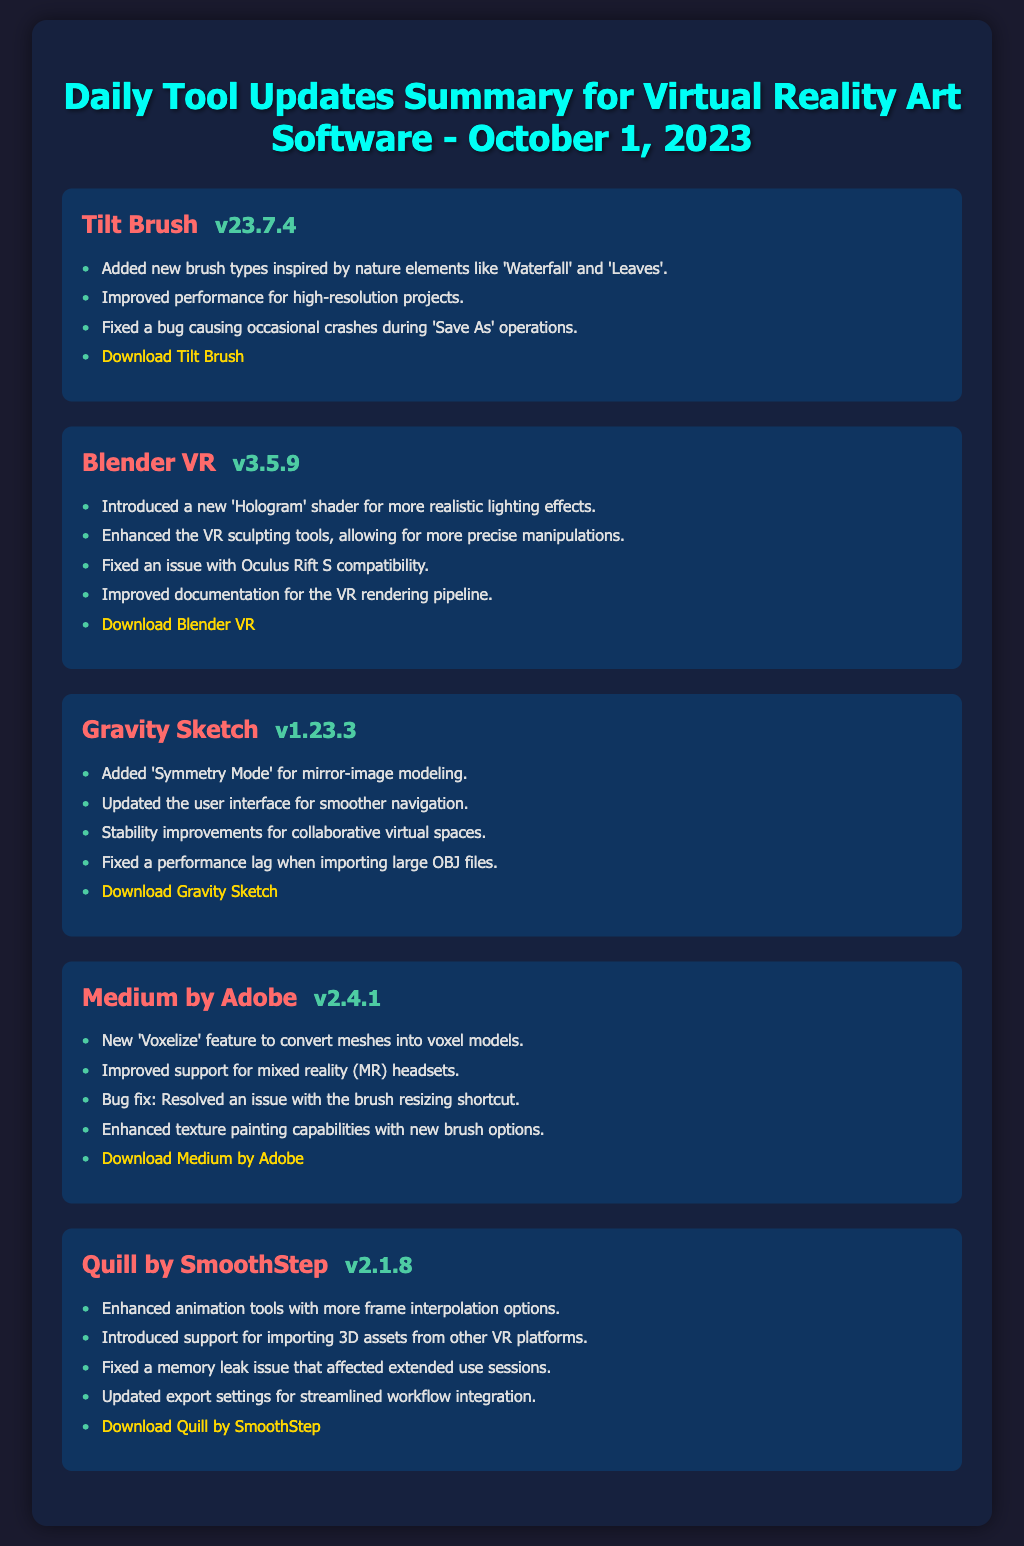What is the latest version of Tilt Brush? The latest version of Tilt Brush listed in the document is v23.7.4.
Answer: v23.7.4 Which new feature was added to Medium by Adobe? A new feature called 'Voxelize' to convert meshes into voxel models was added to Medium by Adobe.
Answer: Voxelize What fixed issue is mentioned for Gravity Sketch? The document notes a fixed performance lag when importing large OBJ files in Gravity Sketch.
Answer: Performance lag How many improvements or additions are listed for Blender VR? There are four improvements or additions listed for Blender VR.
Answer: Four What is the download link for Quill by SmoothStep? The document provides a link for downloading Quill by SmoothStep at https://www.smoothstep.com/quill/download.
Answer: https://www.smoothstep.com/quill/download Which software introduced support for importing 3D assets from other VR platforms? Quill by SmoothStep introduced support for importing 3D assets from other VR platforms.
Answer: Quill by SmoothStep Which software version has improved compatibility with Oculus Rift S? The version 3.5.9 of Blender VR has improved compatibility with Oculus Rift S.
Answer: v3.5.9 What new feature was added to Gravity Sketch? The new feature 'Symmetry Mode' was added for mirror-image modeling in Gravity Sketch.
Answer: Symmetry Mode How many total software updates are summarized in this document? There are five software updates summarized in the document.
Answer: Five 